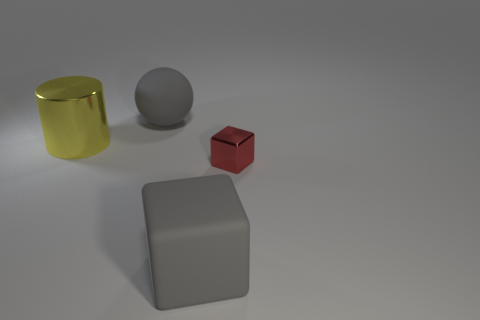Add 3 red shiny cubes. How many objects exist? 7 Subtract all spheres. How many objects are left? 3 Subtract all brown spheres. Subtract all green cubes. How many spheres are left? 1 Subtract all large gray cubes. Subtract all yellow metallic things. How many objects are left? 2 Add 1 metal things. How many metal things are left? 3 Add 3 big yellow cylinders. How many big yellow cylinders exist? 4 Subtract 0 yellow balls. How many objects are left? 4 